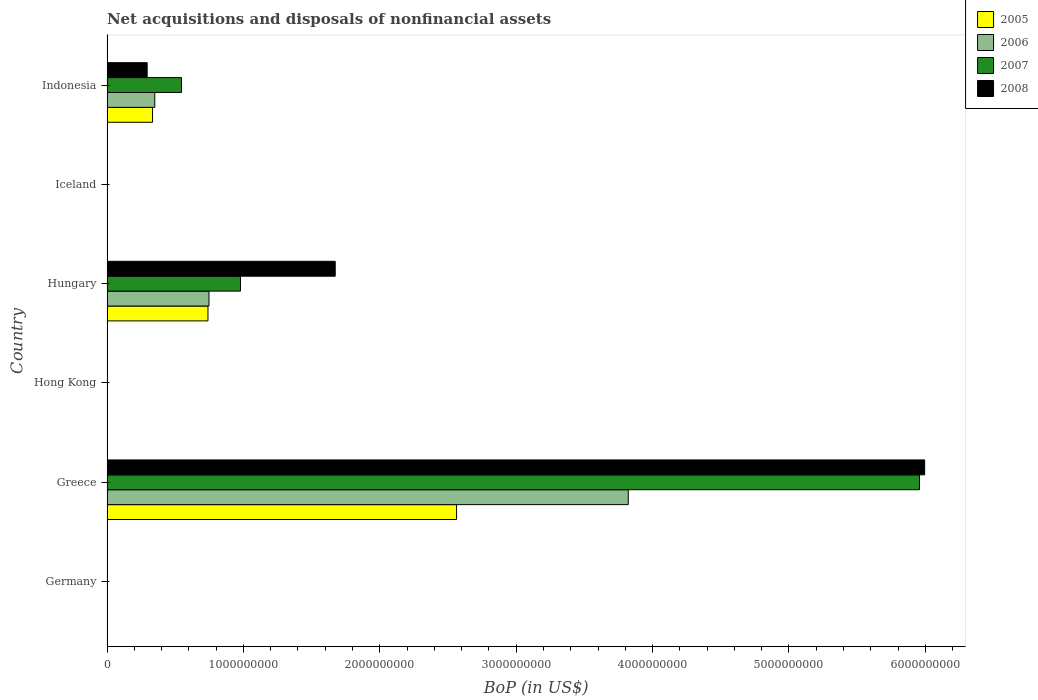Are the number of bars on each tick of the Y-axis equal?
Make the answer very short. No. What is the label of the 2nd group of bars from the top?
Provide a short and direct response. Iceland. In how many cases, is the number of bars for a given country not equal to the number of legend labels?
Keep it short and to the point. 3. What is the Balance of Payments in 2005 in Indonesia?
Your answer should be compact. 3.34e+08. Across all countries, what is the maximum Balance of Payments in 2007?
Provide a succinct answer. 5.96e+09. Across all countries, what is the minimum Balance of Payments in 2006?
Give a very brief answer. 0. In which country was the Balance of Payments in 2005 maximum?
Your response must be concise. Greece. What is the total Balance of Payments in 2007 in the graph?
Your answer should be very brief. 7.48e+09. What is the difference between the Balance of Payments in 2007 in Hungary and that in Indonesia?
Make the answer very short. 4.32e+08. What is the difference between the Balance of Payments in 2006 in Iceland and the Balance of Payments in 2007 in Hong Kong?
Keep it short and to the point. 0. What is the average Balance of Payments in 2005 per country?
Give a very brief answer. 6.06e+08. What is the difference between the Balance of Payments in 2005 and Balance of Payments in 2006 in Greece?
Offer a terse response. -1.26e+09. What is the ratio of the Balance of Payments in 2006 in Greece to that in Indonesia?
Make the answer very short. 10.91. What is the difference between the highest and the second highest Balance of Payments in 2008?
Your response must be concise. 4.32e+09. What is the difference between the highest and the lowest Balance of Payments in 2008?
Ensure brevity in your answer.  6.00e+09. In how many countries, is the Balance of Payments in 2008 greater than the average Balance of Payments in 2008 taken over all countries?
Ensure brevity in your answer.  2. Is it the case that in every country, the sum of the Balance of Payments in 2006 and Balance of Payments in 2005 is greater than the sum of Balance of Payments in 2007 and Balance of Payments in 2008?
Offer a very short reply. No. Is it the case that in every country, the sum of the Balance of Payments in 2007 and Balance of Payments in 2006 is greater than the Balance of Payments in 2008?
Give a very brief answer. No. Are all the bars in the graph horizontal?
Offer a terse response. Yes. How many countries are there in the graph?
Give a very brief answer. 6. What is the difference between two consecutive major ticks on the X-axis?
Provide a short and direct response. 1.00e+09. Are the values on the major ticks of X-axis written in scientific E-notation?
Provide a short and direct response. No. Does the graph contain any zero values?
Keep it short and to the point. Yes. How are the legend labels stacked?
Your answer should be compact. Vertical. What is the title of the graph?
Provide a succinct answer. Net acquisitions and disposals of nonfinancial assets. What is the label or title of the X-axis?
Your response must be concise. BoP (in US$). What is the label or title of the Y-axis?
Offer a terse response. Country. What is the BoP (in US$) of 2007 in Germany?
Offer a very short reply. 0. What is the BoP (in US$) of 2005 in Greece?
Make the answer very short. 2.56e+09. What is the BoP (in US$) of 2006 in Greece?
Provide a short and direct response. 3.82e+09. What is the BoP (in US$) of 2007 in Greece?
Give a very brief answer. 5.96e+09. What is the BoP (in US$) of 2008 in Greece?
Provide a succinct answer. 6.00e+09. What is the BoP (in US$) in 2005 in Hong Kong?
Make the answer very short. 0. What is the BoP (in US$) in 2006 in Hong Kong?
Give a very brief answer. 0. What is the BoP (in US$) in 2005 in Hungary?
Your response must be concise. 7.40e+08. What is the BoP (in US$) of 2006 in Hungary?
Keep it short and to the point. 7.48e+08. What is the BoP (in US$) of 2007 in Hungary?
Ensure brevity in your answer.  9.79e+08. What is the BoP (in US$) in 2008 in Hungary?
Your answer should be very brief. 1.67e+09. What is the BoP (in US$) in 2007 in Iceland?
Offer a terse response. 0. What is the BoP (in US$) in 2005 in Indonesia?
Offer a terse response. 3.34e+08. What is the BoP (in US$) of 2006 in Indonesia?
Ensure brevity in your answer.  3.50e+08. What is the BoP (in US$) in 2007 in Indonesia?
Ensure brevity in your answer.  5.46e+08. What is the BoP (in US$) of 2008 in Indonesia?
Offer a very short reply. 2.94e+08. Across all countries, what is the maximum BoP (in US$) in 2005?
Your answer should be very brief. 2.56e+09. Across all countries, what is the maximum BoP (in US$) in 2006?
Offer a very short reply. 3.82e+09. Across all countries, what is the maximum BoP (in US$) of 2007?
Provide a short and direct response. 5.96e+09. Across all countries, what is the maximum BoP (in US$) in 2008?
Offer a very short reply. 6.00e+09. Across all countries, what is the minimum BoP (in US$) of 2005?
Your answer should be compact. 0. Across all countries, what is the minimum BoP (in US$) of 2006?
Give a very brief answer. 0. Across all countries, what is the minimum BoP (in US$) of 2007?
Offer a terse response. 0. Across all countries, what is the minimum BoP (in US$) of 2008?
Your response must be concise. 0. What is the total BoP (in US$) of 2005 in the graph?
Provide a short and direct response. 3.64e+09. What is the total BoP (in US$) in 2006 in the graph?
Offer a very short reply. 4.92e+09. What is the total BoP (in US$) in 2007 in the graph?
Your answer should be compact. 7.48e+09. What is the total BoP (in US$) of 2008 in the graph?
Make the answer very short. 7.96e+09. What is the difference between the BoP (in US$) of 2005 in Greece and that in Hungary?
Offer a terse response. 1.82e+09. What is the difference between the BoP (in US$) in 2006 in Greece and that in Hungary?
Make the answer very short. 3.07e+09. What is the difference between the BoP (in US$) of 2007 in Greece and that in Hungary?
Provide a succinct answer. 4.98e+09. What is the difference between the BoP (in US$) of 2008 in Greece and that in Hungary?
Give a very brief answer. 4.32e+09. What is the difference between the BoP (in US$) in 2005 in Greece and that in Indonesia?
Make the answer very short. 2.23e+09. What is the difference between the BoP (in US$) of 2006 in Greece and that in Indonesia?
Your answer should be compact. 3.47e+09. What is the difference between the BoP (in US$) in 2007 in Greece and that in Indonesia?
Provide a succinct answer. 5.41e+09. What is the difference between the BoP (in US$) of 2008 in Greece and that in Indonesia?
Give a very brief answer. 5.70e+09. What is the difference between the BoP (in US$) in 2005 in Hungary and that in Indonesia?
Keep it short and to the point. 4.06e+08. What is the difference between the BoP (in US$) in 2006 in Hungary and that in Indonesia?
Offer a terse response. 3.97e+08. What is the difference between the BoP (in US$) of 2007 in Hungary and that in Indonesia?
Keep it short and to the point. 4.32e+08. What is the difference between the BoP (in US$) in 2008 in Hungary and that in Indonesia?
Offer a terse response. 1.38e+09. What is the difference between the BoP (in US$) of 2005 in Greece and the BoP (in US$) of 2006 in Hungary?
Provide a succinct answer. 1.82e+09. What is the difference between the BoP (in US$) of 2005 in Greece and the BoP (in US$) of 2007 in Hungary?
Provide a short and direct response. 1.58e+09. What is the difference between the BoP (in US$) of 2005 in Greece and the BoP (in US$) of 2008 in Hungary?
Your answer should be compact. 8.90e+08. What is the difference between the BoP (in US$) in 2006 in Greece and the BoP (in US$) in 2007 in Hungary?
Your answer should be very brief. 2.84e+09. What is the difference between the BoP (in US$) in 2006 in Greece and the BoP (in US$) in 2008 in Hungary?
Make the answer very short. 2.15e+09. What is the difference between the BoP (in US$) in 2007 in Greece and the BoP (in US$) in 2008 in Hungary?
Your answer should be very brief. 4.28e+09. What is the difference between the BoP (in US$) of 2005 in Greece and the BoP (in US$) of 2006 in Indonesia?
Offer a terse response. 2.21e+09. What is the difference between the BoP (in US$) of 2005 in Greece and the BoP (in US$) of 2007 in Indonesia?
Ensure brevity in your answer.  2.02e+09. What is the difference between the BoP (in US$) in 2005 in Greece and the BoP (in US$) in 2008 in Indonesia?
Your response must be concise. 2.27e+09. What is the difference between the BoP (in US$) in 2006 in Greece and the BoP (in US$) in 2007 in Indonesia?
Ensure brevity in your answer.  3.28e+09. What is the difference between the BoP (in US$) in 2006 in Greece and the BoP (in US$) in 2008 in Indonesia?
Offer a very short reply. 3.53e+09. What is the difference between the BoP (in US$) in 2007 in Greece and the BoP (in US$) in 2008 in Indonesia?
Your answer should be very brief. 5.66e+09. What is the difference between the BoP (in US$) of 2005 in Hungary and the BoP (in US$) of 2006 in Indonesia?
Ensure brevity in your answer.  3.90e+08. What is the difference between the BoP (in US$) of 2005 in Hungary and the BoP (in US$) of 2007 in Indonesia?
Make the answer very short. 1.94e+08. What is the difference between the BoP (in US$) in 2005 in Hungary and the BoP (in US$) in 2008 in Indonesia?
Provide a short and direct response. 4.46e+08. What is the difference between the BoP (in US$) of 2006 in Hungary and the BoP (in US$) of 2007 in Indonesia?
Give a very brief answer. 2.01e+08. What is the difference between the BoP (in US$) of 2006 in Hungary and the BoP (in US$) of 2008 in Indonesia?
Your response must be concise. 4.53e+08. What is the difference between the BoP (in US$) of 2007 in Hungary and the BoP (in US$) of 2008 in Indonesia?
Provide a short and direct response. 6.84e+08. What is the average BoP (in US$) of 2005 per country?
Your answer should be very brief. 6.06e+08. What is the average BoP (in US$) of 2006 per country?
Offer a terse response. 8.20e+08. What is the average BoP (in US$) in 2007 per country?
Keep it short and to the point. 1.25e+09. What is the average BoP (in US$) in 2008 per country?
Your response must be concise. 1.33e+09. What is the difference between the BoP (in US$) in 2005 and BoP (in US$) in 2006 in Greece?
Provide a short and direct response. -1.26e+09. What is the difference between the BoP (in US$) in 2005 and BoP (in US$) in 2007 in Greece?
Offer a terse response. -3.39e+09. What is the difference between the BoP (in US$) of 2005 and BoP (in US$) of 2008 in Greece?
Give a very brief answer. -3.43e+09. What is the difference between the BoP (in US$) of 2006 and BoP (in US$) of 2007 in Greece?
Provide a succinct answer. -2.14e+09. What is the difference between the BoP (in US$) in 2006 and BoP (in US$) in 2008 in Greece?
Offer a very short reply. -2.17e+09. What is the difference between the BoP (in US$) of 2007 and BoP (in US$) of 2008 in Greece?
Ensure brevity in your answer.  -3.82e+07. What is the difference between the BoP (in US$) of 2005 and BoP (in US$) of 2006 in Hungary?
Your answer should be very brief. -7.44e+06. What is the difference between the BoP (in US$) in 2005 and BoP (in US$) in 2007 in Hungary?
Your response must be concise. -2.38e+08. What is the difference between the BoP (in US$) in 2005 and BoP (in US$) in 2008 in Hungary?
Provide a short and direct response. -9.33e+08. What is the difference between the BoP (in US$) in 2006 and BoP (in US$) in 2007 in Hungary?
Provide a short and direct response. -2.31e+08. What is the difference between the BoP (in US$) of 2006 and BoP (in US$) of 2008 in Hungary?
Offer a terse response. -9.26e+08. What is the difference between the BoP (in US$) in 2007 and BoP (in US$) in 2008 in Hungary?
Provide a short and direct response. -6.95e+08. What is the difference between the BoP (in US$) of 2005 and BoP (in US$) of 2006 in Indonesia?
Your answer should be compact. -1.64e+07. What is the difference between the BoP (in US$) of 2005 and BoP (in US$) of 2007 in Indonesia?
Provide a short and direct response. -2.12e+08. What is the difference between the BoP (in US$) in 2005 and BoP (in US$) in 2008 in Indonesia?
Provide a succinct answer. 3.95e+07. What is the difference between the BoP (in US$) in 2006 and BoP (in US$) in 2007 in Indonesia?
Your response must be concise. -1.96e+08. What is the difference between the BoP (in US$) of 2006 and BoP (in US$) of 2008 in Indonesia?
Your answer should be very brief. 5.59e+07. What is the difference between the BoP (in US$) in 2007 and BoP (in US$) in 2008 in Indonesia?
Give a very brief answer. 2.52e+08. What is the ratio of the BoP (in US$) in 2005 in Greece to that in Hungary?
Your answer should be compact. 3.46. What is the ratio of the BoP (in US$) in 2006 in Greece to that in Hungary?
Your answer should be compact. 5.11. What is the ratio of the BoP (in US$) in 2007 in Greece to that in Hungary?
Offer a terse response. 6.09. What is the ratio of the BoP (in US$) in 2008 in Greece to that in Hungary?
Keep it short and to the point. 3.58. What is the ratio of the BoP (in US$) of 2005 in Greece to that in Indonesia?
Your answer should be very brief. 7.68. What is the ratio of the BoP (in US$) in 2006 in Greece to that in Indonesia?
Give a very brief answer. 10.91. What is the ratio of the BoP (in US$) of 2007 in Greece to that in Indonesia?
Keep it short and to the point. 10.91. What is the ratio of the BoP (in US$) in 2008 in Greece to that in Indonesia?
Your response must be concise. 20.36. What is the ratio of the BoP (in US$) in 2005 in Hungary to that in Indonesia?
Ensure brevity in your answer.  2.22. What is the ratio of the BoP (in US$) of 2006 in Hungary to that in Indonesia?
Provide a succinct answer. 2.13. What is the ratio of the BoP (in US$) of 2007 in Hungary to that in Indonesia?
Make the answer very short. 1.79. What is the ratio of the BoP (in US$) in 2008 in Hungary to that in Indonesia?
Provide a short and direct response. 5.68. What is the difference between the highest and the second highest BoP (in US$) of 2005?
Provide a succinct answer. 1.82e+09. What is the difference between the highest and the second highest BoP (in US$) of 2006?
Ensure brevity in your answer.  3.07e+09. What is the difference between the highest and the second highest BoP (in US$) in 2007?
Your response must be concise. 4.98e+09. What is the difference between the highest and the second highest BoP (in US$) of 2008?
Your response must be concise. 4.32e+09. What is the difference between the highest and the lowest BoP (in US$) of 2005?
Ensure brevity in your answer.  2.56e+09. What is the difference between the highest and the lowest BoP (in US$) in 2006?
Offer a very short reply. 3.82e+09. What is the difference between the highest and the lowest BoP (in US$) in 2007?
Give a very brief answer. 5.96e+09. What is the difference between the highest and the lowest BoP (in US$) of 2008?
Your response must be concise. 6.00e+09. 